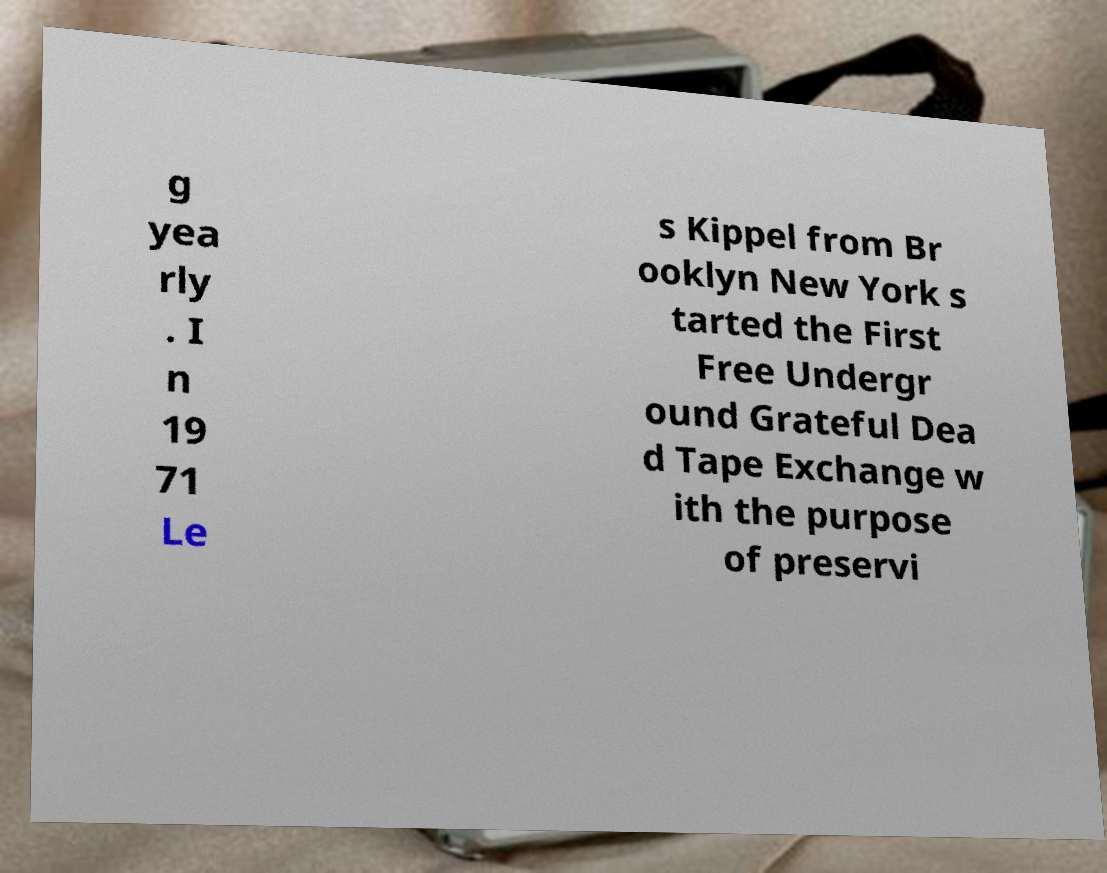Could you extract and type out the text from this image? g yea rly . I n 19 71 Le s Kippel from Br ooklyn New York s tarted the First Free Undergr ound Grateful Dea d Tape Exchange w ith the purpose of preservi 